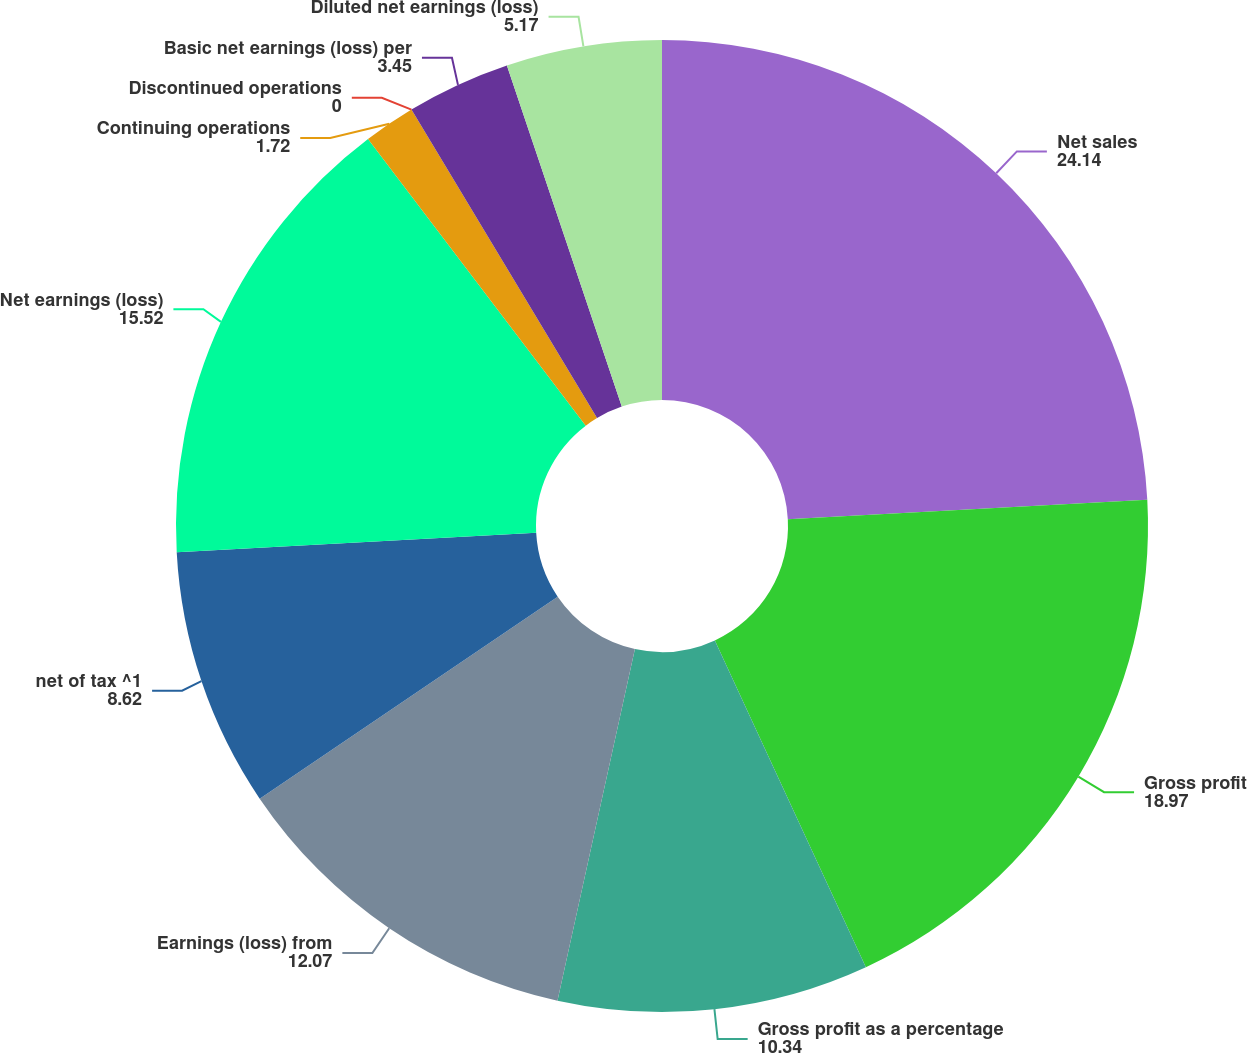Convert chart. <chart><loc_0><loc_0><loc_500><loc_500><pie_chart><fcel>Net sales<fcel>Gross profit<fcel>Gross profit as a percentage<fcel>Earnings (loss) from<fcel>net of tax ^1<fcel>Net earnings (loss)<fcel>Continuing operations<fcel>Discontinued operations<fcel>Basic net earnings (loss) per<fcel>Diluted net earnings (loss)<nl><fcel>24.14%<fcel>18.97%<fcel>10.34%<fcel>12.07%<fcel>8.62%<fcel>15.52%<fcel>1.72%<fcel>0.0%<fcel>3.45%<fcel>5.17%<nl></chart> 